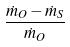<formula> <loc_0><loc_0><loc_500><loc_500>\frac { \dot { m } _ { O } - \dot { m } _ { S } } { \dot { m } _ { O } }</formula> 